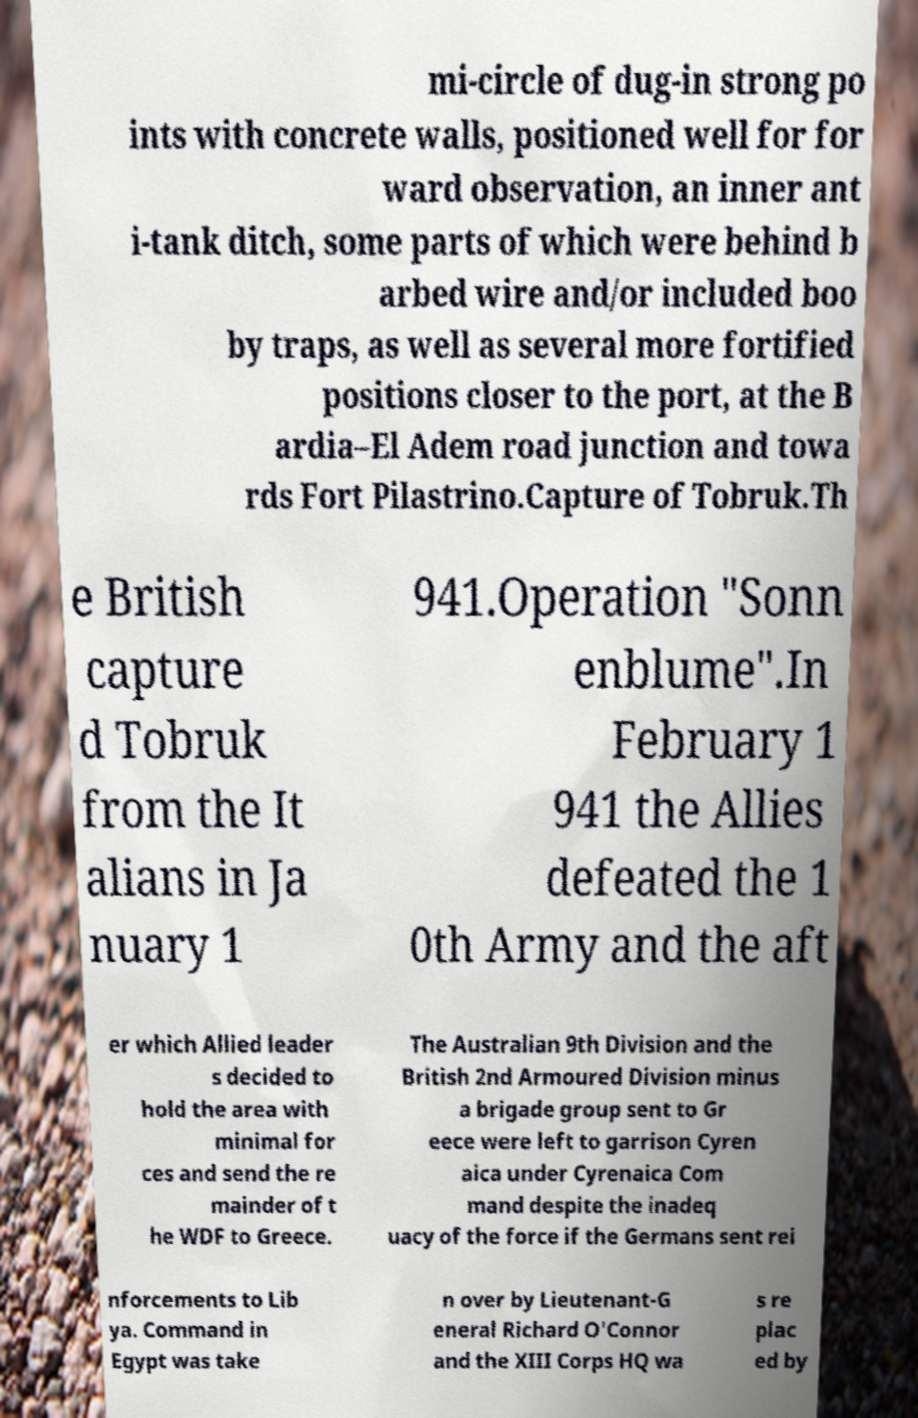Please read and relay the text visible in this image. What does it say? mi-circle of dug-in strong po ints with concrete walls, positioned well for for ward observation, an inner ant i-tank ditch, some parts of which were behind b arbed wire and/or included boo by traps, as well as several more fortified positions closer to the port, at the B ardia–El Adem road junction and towa rds Fort Pilastrino.Capture of Tobruk.Th e British capture d Tobruk from the It alians in Ja nuary 1 941.Operation "Sonn enblume".In February 1 941 the Allies defeated the 1 0th Army and the aft er which Allied leader s decided to hold the area with minimal for ces and send the re mainder of t he WDF to Greece. The Australian 9th Division and the British 2nd Armoured Division minus a brigade group sent to Gr eece were left to garrison Cyren aica under Cyrenaica Com mand despite the inadeq uacy of the force if the Germans sent rei nforcements to Lib ya. Command in Egypt was take n over by Lieutenant-G eneral Richard O'Connor and the XIII Corps HQ wa s re plac ed by 